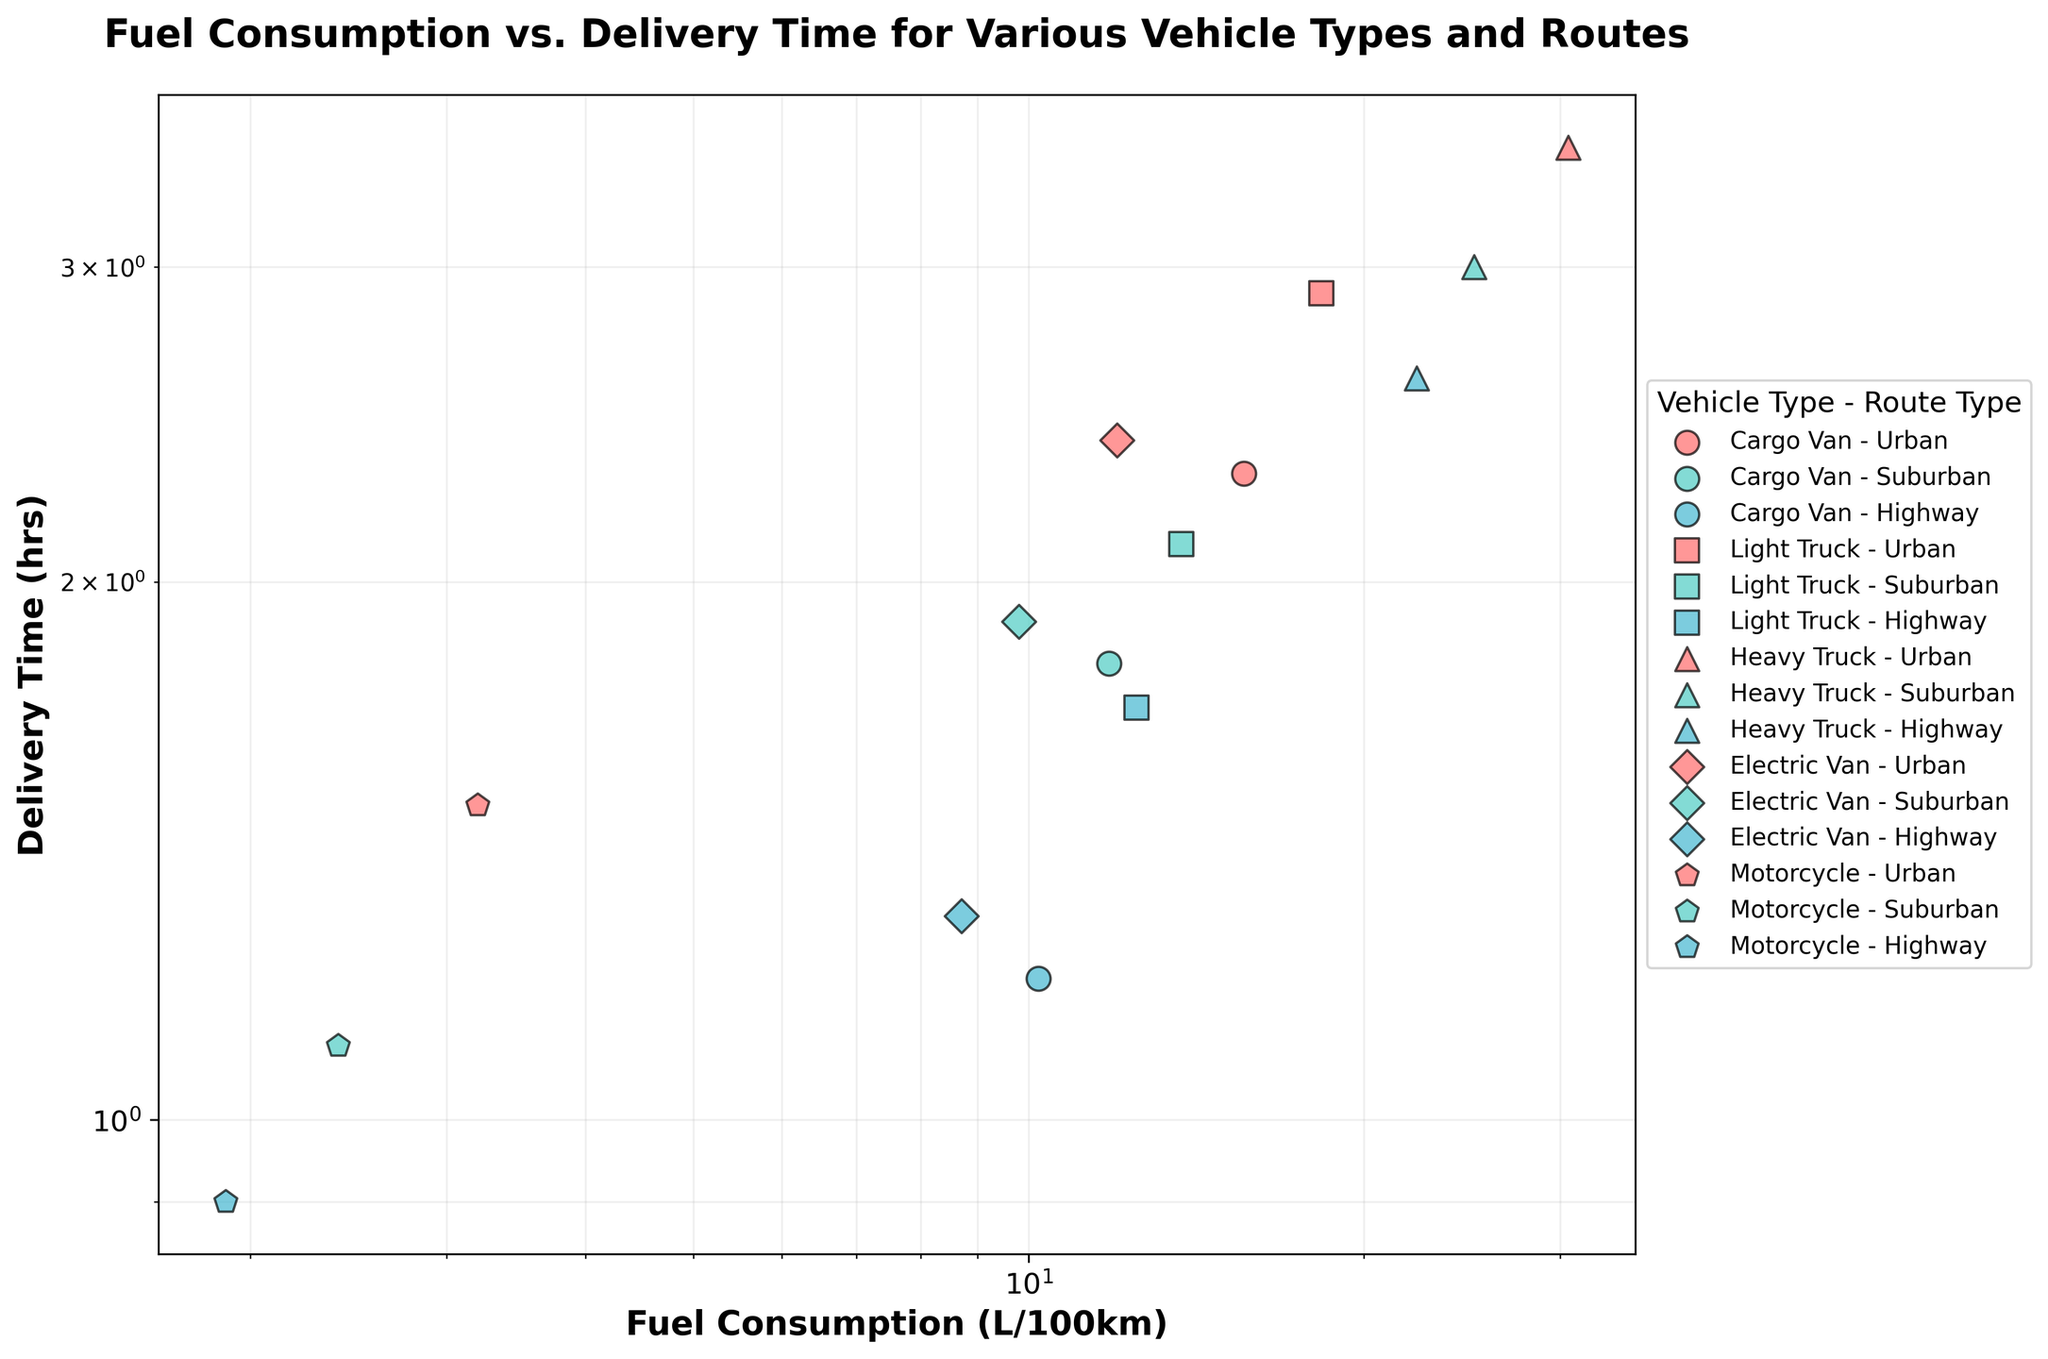What is the title of the figure? The title is usually displayed at the top of the figure. Here, the title clearly states the analysis focus.
Answer: "Fuel Consumption vs. Delivery Time for Various Vehicle Types and Routes" Which vehicle type has the highest fuel consumption for urban routes? By looking at the data points on the scatter plot, find the highest fuel consumption point for urban routes (colored in red).
Answer: Heavy Truck What is the delivery time for an electric van on a suburban route? Find the data point representing an electric van on a suburban route (colored in teal and shaped like a diamond) and read the corresponding delivery time.
Answer: 1.9 hours Compare the fuel consumption of motorcycles in urban routes to that in suburban routes. Which one is higher? Identify data points for motorcycles in both urban and suburban routes and compare their positions on the x-axis (fuel consumption).
Answer: Urban route What is the average delivery time for heavy trucks across all route types? To calculate the average, sum the delivery times for heavy trucks across urban, suburban, and highway routes and divide by the number of routes. The delivery times are 3.5, 3.0, and 2.6 hours. Average = (3.5 + 3.0 + 2.6) / 3
Answer: 3.03 hours Which vehicle type and route combination has the lowest fuel consumption? Find the data point with the lowest x-axis value on the scatter plot and note the corresponding vehicle type and route.
Answer: Motorcycle - Highway What is the relationship between fuel consumption and delivery time for cargo vans? Does it increase or decrease? Observe the scatter points for cargo vans across different routes and see if higher fuel consumption corresponds to higher or lower delivery times.
Answer: Generally increases Compare the fuel consumption of heavy trucks to light trucks on highway routes. Which one consumes more? Look at the points for heavy trucks and light trucks in the highway route category and compare their positions on the x-axis.
Answer: Heavy Truck What is the difference in fuel consumption between a cargo van and a light truck on a suburban route? Find and subtract the fuel consumption values of a cargo van and a light truck on a suburban route. Light Truck: 13.7 L/100km, Cargo Van: 11.8 L/100km. Difference = 13.7 - 11.8
Answer: 1.9 L/100km In which route type does the motorcycle have nearly the same delivery time as any other vehicle type? Look for motorcycle points and compare their delivery times to other vehicles across urban, suburban, and highway routes.
Answer: Suburban 